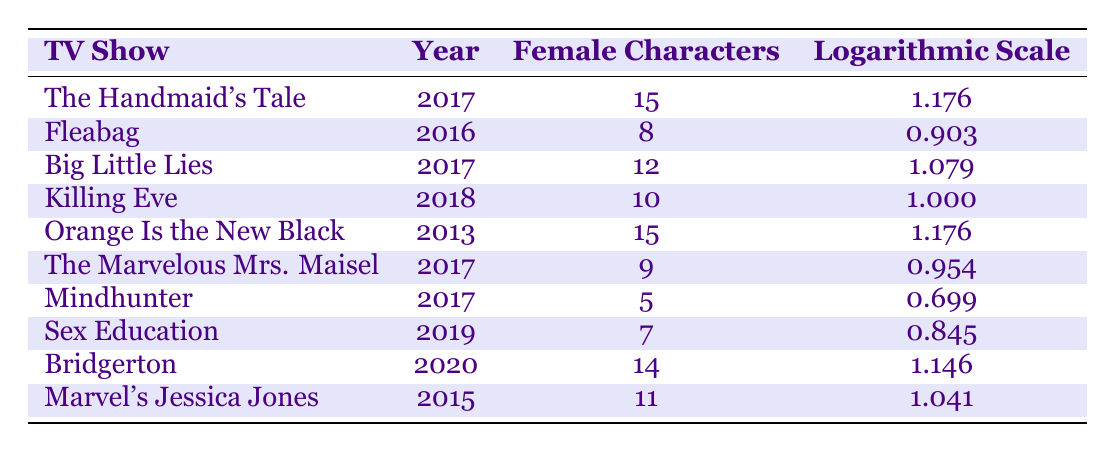What is the title of the TV show that has the highest number of female characters? From the table, "The Handmaid's Tale" and "Orange Is the New Black" both have the highest number of female characters listed, which is 15.
Answer: The Handmaid's Tale and Orange Is the New Black Which TV show from 2017 features 12 female characters? According to the table, "Big Little Lies" is listed in the year 2017 with 12 female characters.
Answer: Big Little Lies What is the average number of female characters across all shows listed? To find the average, add all female character counts (15 + 8 + 12 + 10 + 15 + 9 + 5 + 7 + 14 + 11) = 96 and divide by the number of shows (10). Thus, 96/10 = 9.6.
Answer: 9.6 Is there any show from 2019 that has more than 8 female characters? Yes, the show "Bridgerton," listed in the year 2020, has 14 female characters, and "Killing Eve" from 2018 has 10 female characters. Hence, there are shows after 2019 with more than 8 characters.
Answer: Yes Which TV show has a logarithmic scale value greater than 1.1 and features 14 female characters? The show "Bridgerton" has a logarithmic scale value of 1.146 and features 14 female characters.
Answer: Bridgerton How many female characters are there in total for the shows produced before 2016? The shows "Orange Is the New Black" (15 female characters) and "Marvel's Jessica Jones" (11 female characters) were produced before 2016, for a total of 15 + 11 = 26 female characters in these shows.
Answer: 26 Are there any shows with logarithmic scale values less than 0.8? No, the lowest logarithmic scale value in the table is 0.699 (from "Mindhunter"), which is still above 0.8.
Answer: No How many more female characters does "The Handmaid's Tale" have compared to "Fleabag"? "The Handmaid's Tale" has 15 female characters, while "Fleabag" has 8. The difference is 15 - 8 = 7 female characters.
Answer: 7 